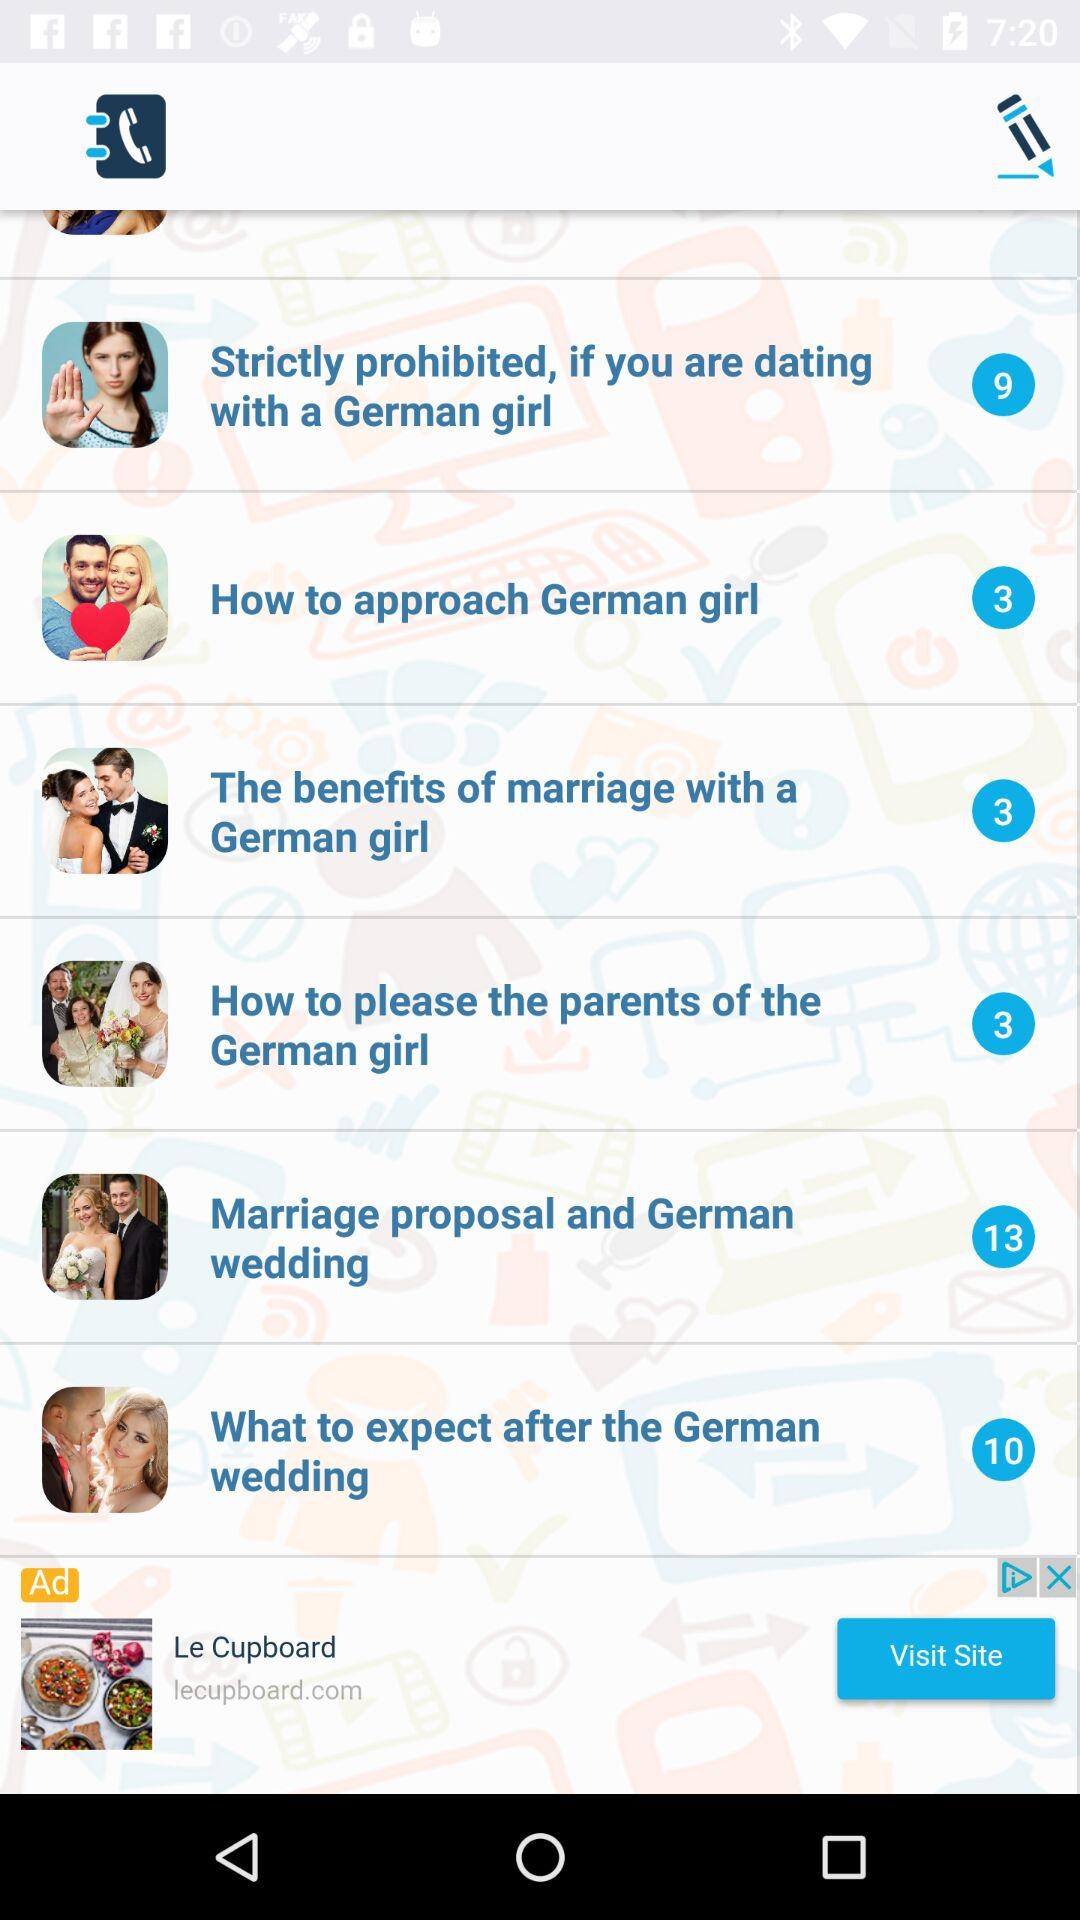What is the total number of tips on how to approach German girls? The total number of tips is 3. 